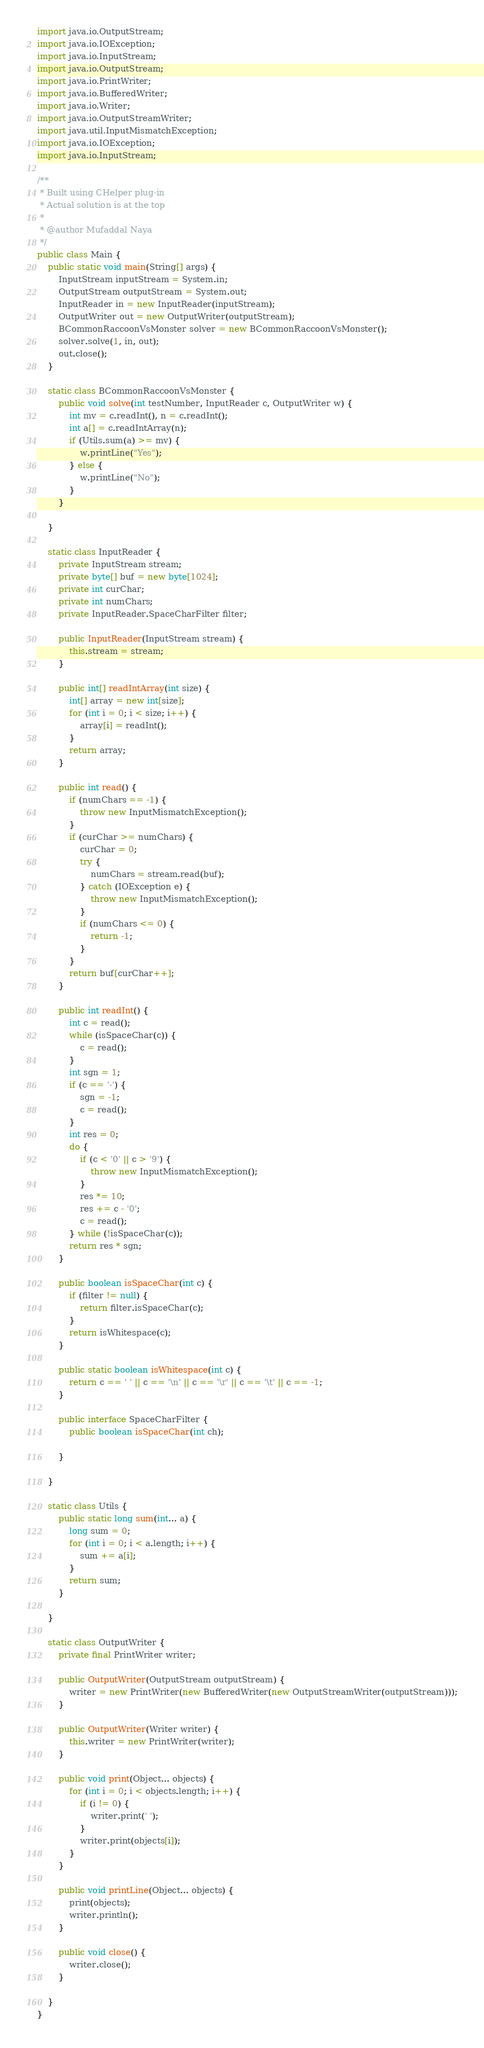Convert code to text. <code><loc_0><loc_0><loc_500><loc_500><_Java_>import java.io.OutputStream;
import java.io.IOException;
import java.io.InputStream;
import java.io.OutputStream;
import java.io.PrintWriter;
import java.io.BufferedWriter;
import java.io.Writer;
import java.io.OutputStreamWriter;
import java.util.InputMismatchException;
import java.io.IOException;
import java.io.InputStream;

/**
 * Built using CHelper plug-in
 * Actual solution is at the top
 *
 * @author Mufaddal Naya
 */
public class Main {
    public static void main(String[] args) {
        InputStream inputStream = System.in;
        OutputStream outputStream = System.out;
        InputReader in = new InputReader(inputStream);
        OutputWriter out = new OutputWriter(outputStream);
        BCommonRaccoonVsMonster solver = new BCommonRaccoonVsMonster();
        solver.solve(1, in, out);
        out.close();
    }

    static class BCommonRaccoonVsMonster {
        public void solve(int testNumber, InputReader c, OutputWriter w) {
            int mv = c.readInt(), n = c.readInt();
            int a[] = c.readIntArray(n);
            if (Utils.sum(a) >= mv) {
                w.printLine("Yes");
            } else {
                w.printLine("No");
            }
        }

    }

    static class InputReader {
        private InputStream stream;
        private byte[] buf = new byte[1024];
        private int curChar;
        private int numChars;
        private InputReader.SpaceCharFilter filter;

        public InputReader(InputStream stream) {
            this.stream = stream;
        }

        public int[] readIntArray(int size) {
            int[] array = new int[size];
            for (int i = 0; i < size; i++) {
                array[i] = readInt();
            }
            return array;
        }

        public int read() {
            if (numChars == -1) {
                throw new InputMismatchException();
            }
            if (curChar >= numChars) {
                curChar = 0;
                try {
                    numChars = stream.read(buf);
                } catch (IOException e) {
                    throw new InputMismatchException();
                }
                if (numChars <= 0) {
                    return -1;
                }
            }
            return buf[curChar++];
        }

        public int readInt() {
            int c = read();
            while (isSpaceChar(c)) {
                c = read();
            }
            int sgn = 1;
            if (c == '-') {
                sgn = -1;
                c = read();
            }
            int res = 0;
            do {
                if (c < '0' || c > '9') {
                    throw new InputMismatchException();
                }
                res *= 10;
                res += c - '0';
                c = read();
            } while (!isSpaceChar(c));
            return res * sgn;
        }

        public boolean isSpaceChar(int c) {
            if (filter != null) {
                return filter.isSpaceChar(c);
            }
            return isWhitespace(c);
        }

        public static boolean isWhitespace(int c) {
            return c == ' ' || c == '\n' || c == '\r' || c == '\t' || c == -1;
        }

        public interface SpaceCharFilter {
            public boolean isSpaceChar(int ch);

        }

    }

    static class Utils {
        public static long sum(int... a) {
            long sum = 0;
            for (int i = 0; i < a.length; i++) {
                sum += a[i];
            }
            return sum;
        }

    }

    static class OutputWriter {
        private final PrintWriter writer;

        public OutputWriter(OutputStream outputStream) {
            writer = new PrintWriter(new BufferedWriter(new OutputStreamWriter(outputStream)));
        }

        public OutputWriter(Writer writer) {
            this.writer = new PrintWriter(writer);
        }

        public void print(Object... objects) {
            for (int i = 0; i < objects.length; i++) {
                if (i != 0) {
                    writer.print(' ');
                }
                writer.print(objects[i]);
            }
        }

        public void printLine(Object... objects) {
            print(objects);
            writer.println();
        }

        public void close() {
            writer.close();
        }

    }
}

</code> 